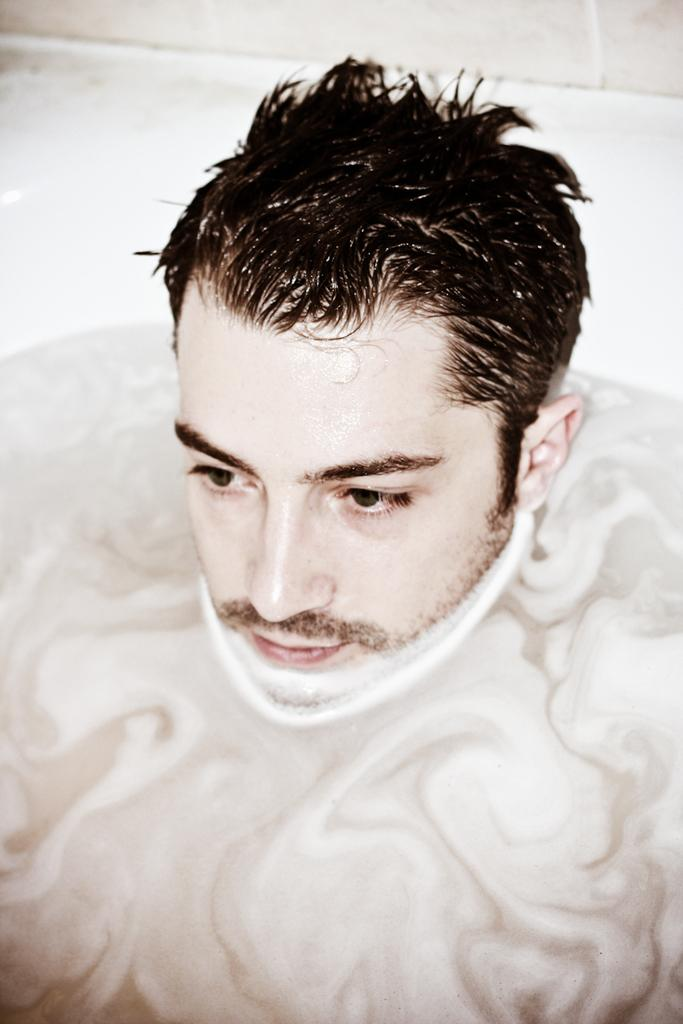What is the main subject of the image? There is a person in the water in the image. Can you describe the person's activity in the image? The person is in the water, but their specific activity is not clear from the provided facts. What is the setting of the image? The setting of the image is in or near water. What type of bear can be seen swimming alongside the person in the image? There is no bear present in the image; it only features a person in the water. 